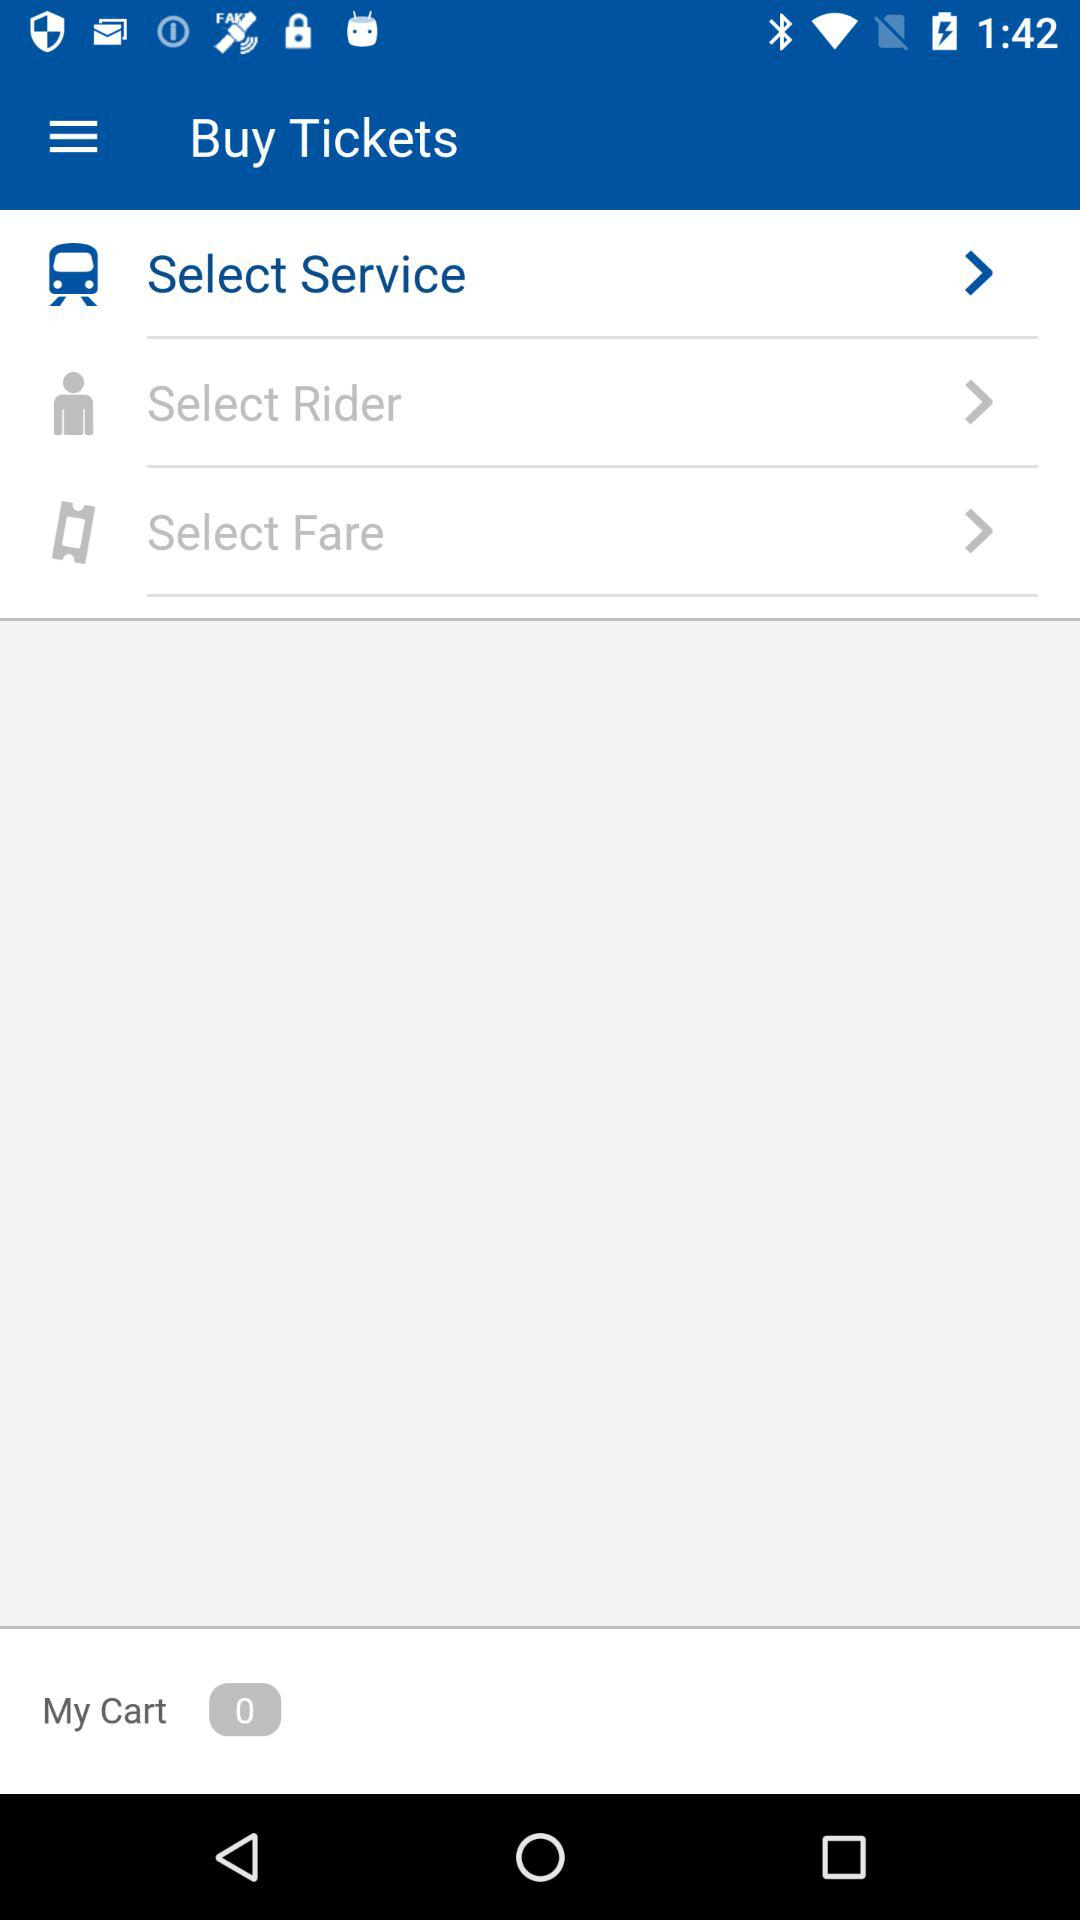Which option is selected? The selected option is "Select Service". 